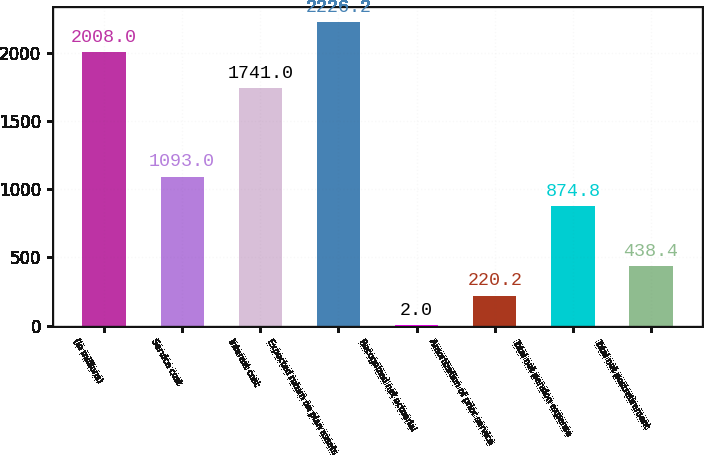Convert chart. <chart><loc_0><loc_0><loc_500><loc_500><bar_chart><fcel>(In millions)<fcel>Service cost<fcel>Interest cost<fcel>Expected return on plan assets<fcel>Recognized net actuarial<fcel>Amortization of prior service<fcel>Total net pension expense<fcel>Total net postretirement<nl><fcel>2008<fcel>1093<fcel>1741<fcel>2226.2<fcel>2<fcel>220.2<fcel>874.8<fcel>438.4<nl></chart> 